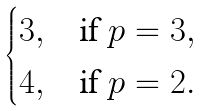Convert formula to latex. <formula><loc_0><loc_0><loc_500><loc_500>\begin{cases} 3 , & \text {if } p = 3 , \\ 4 , & \text {if } p = 2 . \end{cases}</formula> 